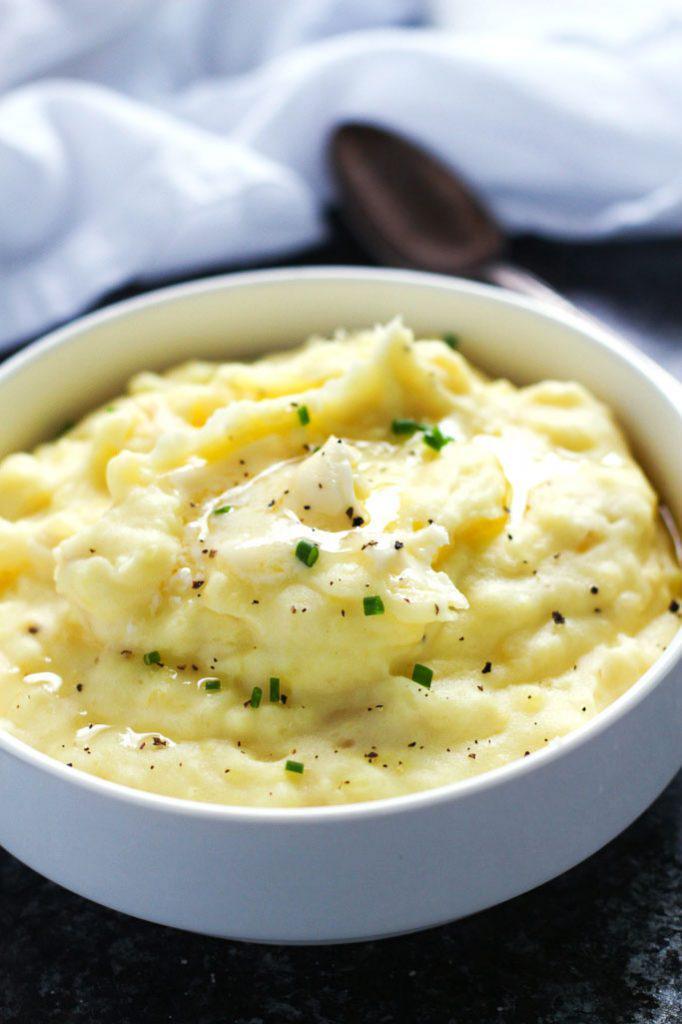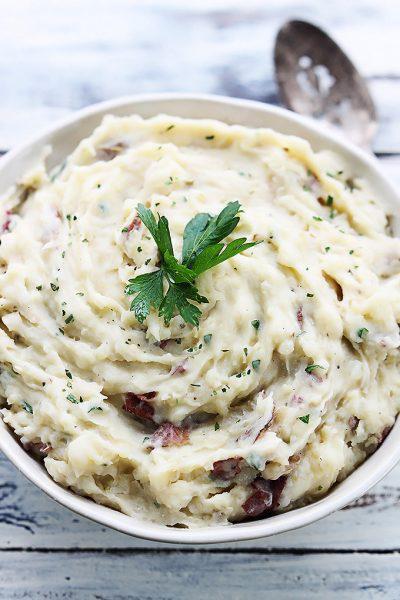The first image is the image on the left, the second image is the image on the right. Assess this claim about the two images: "Every serving of mashed potatoes has a green herb in it, and one serving appears more buttery or yellow than the other.". Correct or not? Answer yes or no. Yes. The first image is the image on the left, the second image is the image on the right. Analyze the images presented: Is the assertion "The left and right image contains the same of white serving dishes that hold mash potatoes." valid? Answer yes or no. Yes. 